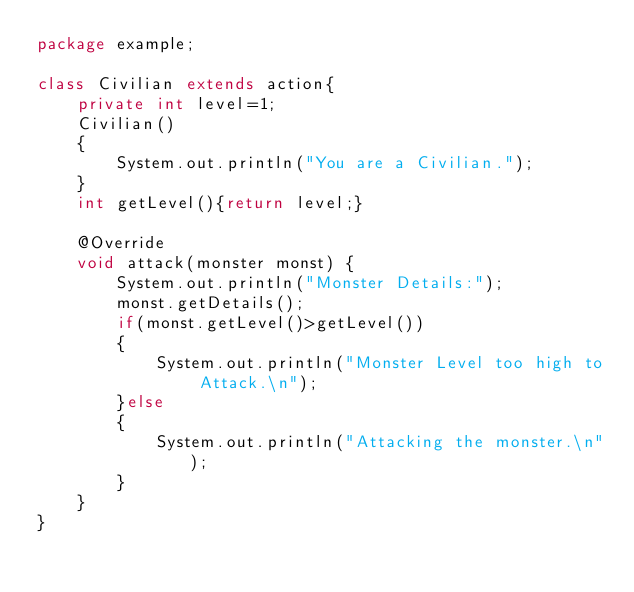<code> <loc_0><loc_0><loc_500><loc_500><_Java_>package example;

class Civilian extends action{
    private int level=1;
    Civilian()
    {
        System.out.println("You are a Civilian.");
    }
    int getLevel(){return level;}

    @Override
    void attack(monster monst) {
        System.out.println("Monster Details:");
        monst.getDetails();
        if(monst.getLevel()>getLevel())
        {
            System.out.println("Monster Level too high to Attack.\n");
        }else
        {
            System.out.println("Attacking the monster.\n");
        }
    }  
}
</code> 